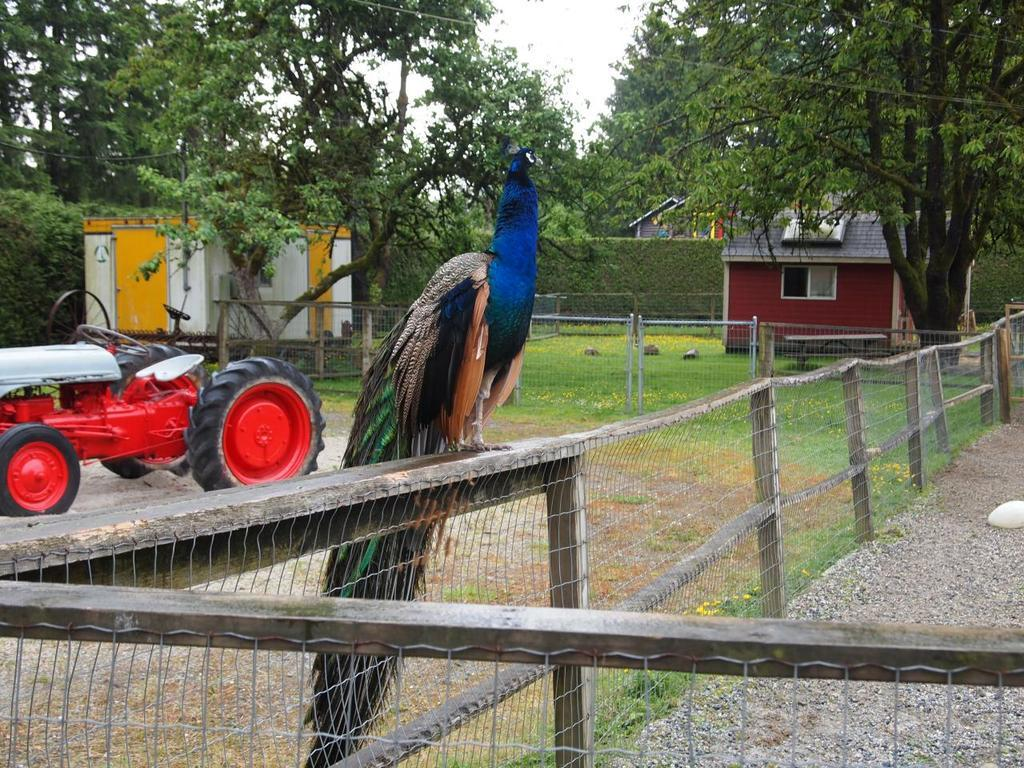What animal is the main subject of the image? There is a peacock in the image. Where is the peacock located in the image? The peacock is standing on a wooden fence. What can be seen in the background of the image? There are trees, sky, and buildings visible in the background of the image. What type of vehicle is present on the ground in the image? A motor vehicle is present on the ground in the image. What additional object can be seen in the image? There is a generator in the image. What time of day is it in the image, given that it appears to be night? The image does not depict nighttime; the sky is visible in the background, and there is no indication of darkness. 